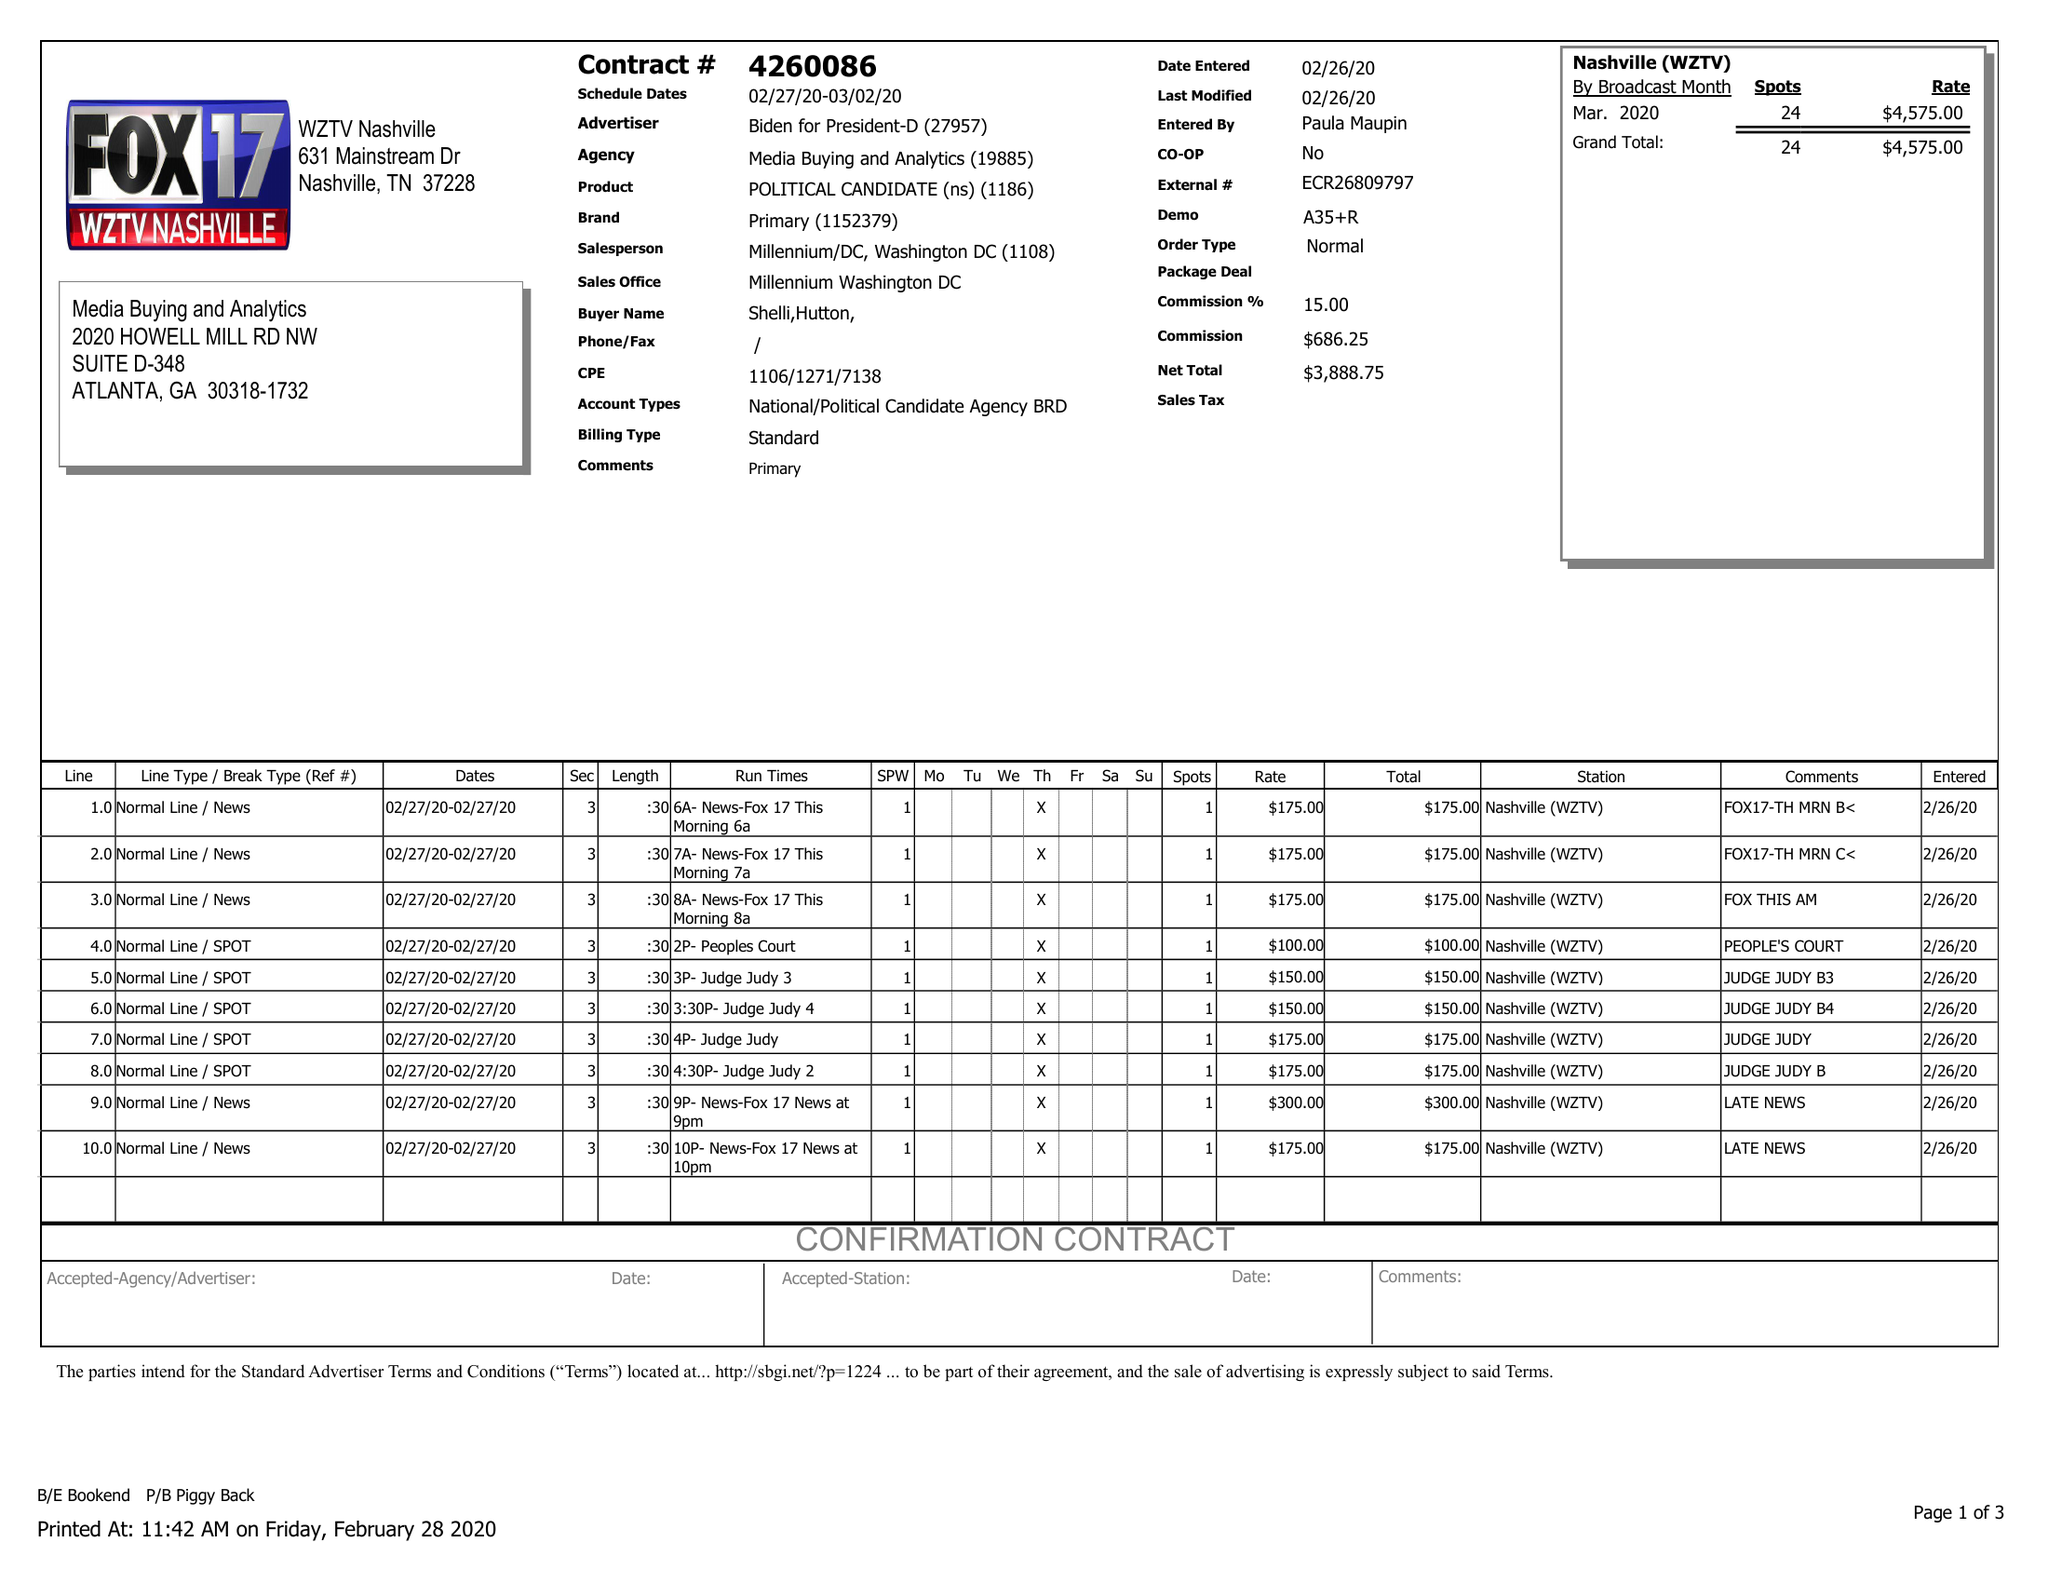What is the value for the gross_amount?
Answer the question using a single word or phrase. 4575.00 